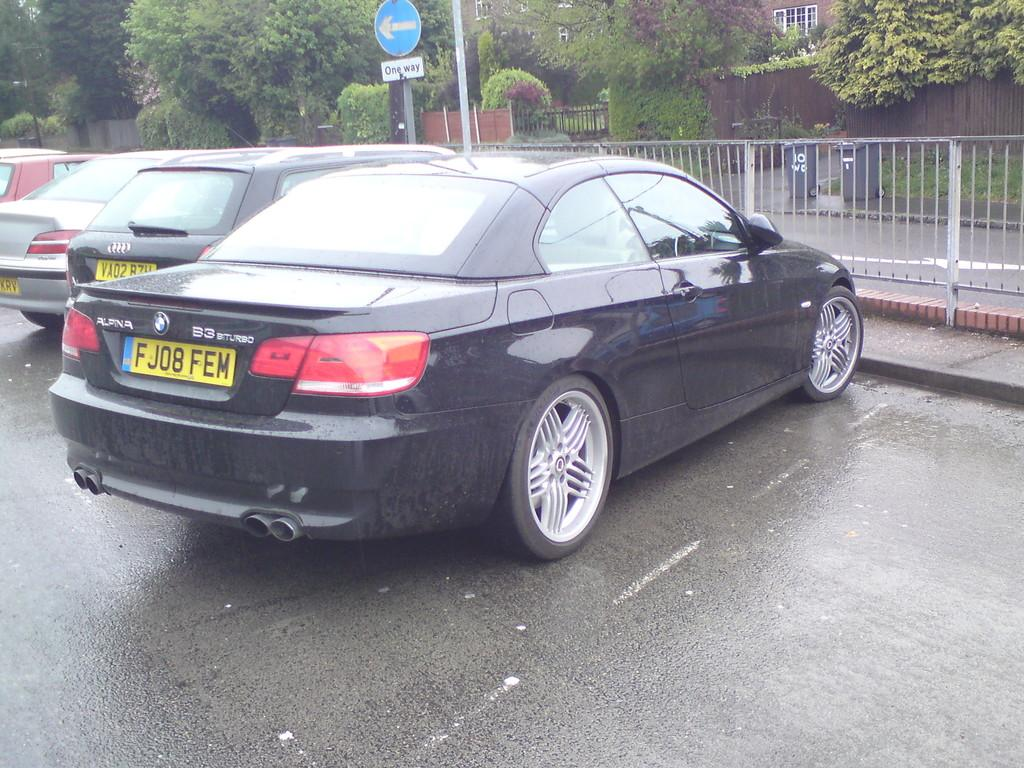What can be seen on the road in the image? There are cars parked on the road in the image. What is the barrier between the road and the building in the image? There is a fence in the image. What type of structure is visible in the image? There is a building in the image. What is in front of the building in the image? There are trees in front of the building in the image. Where can trash be disposed of in the image? There are two trash bins in the image. Is there a veil covering the building in the image? No, there is no veil present in the image. How does the snow affect the visibility of the cars in the image? There is no snow present in the image, so it does not affect the visibility of the cars. 